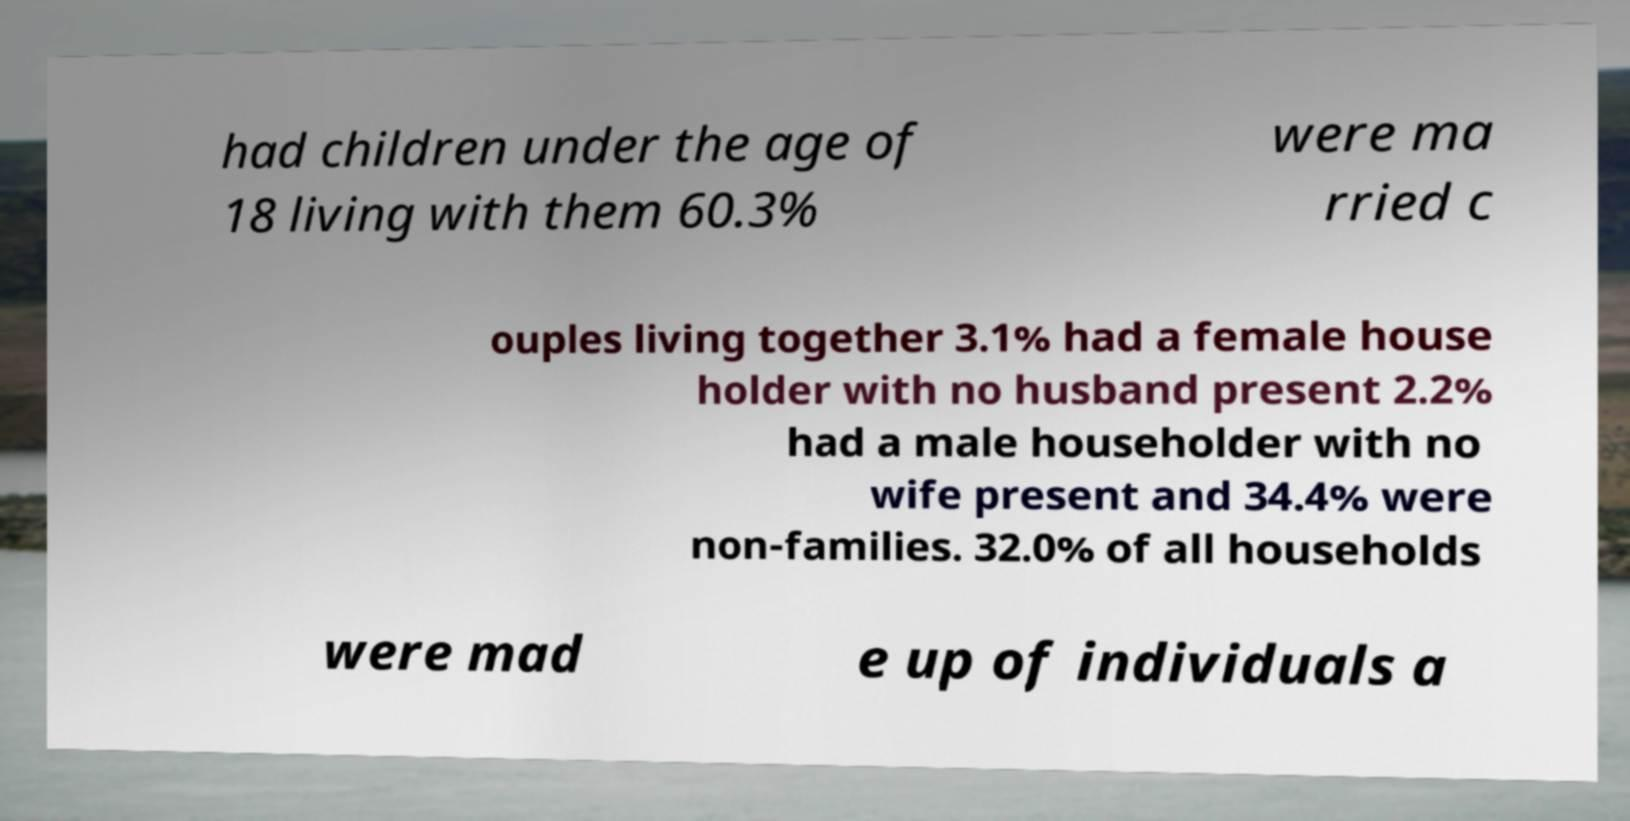Could you extract and type out the text from this image? had children under the age of 18 living with them 60.3% were ma rried c ouples living together 3.1% had a female house holder with no husband present 2.2% had a male householder with no wife present and 34.4% were non-families. 32.0% of all households were mad e up of individuals a 